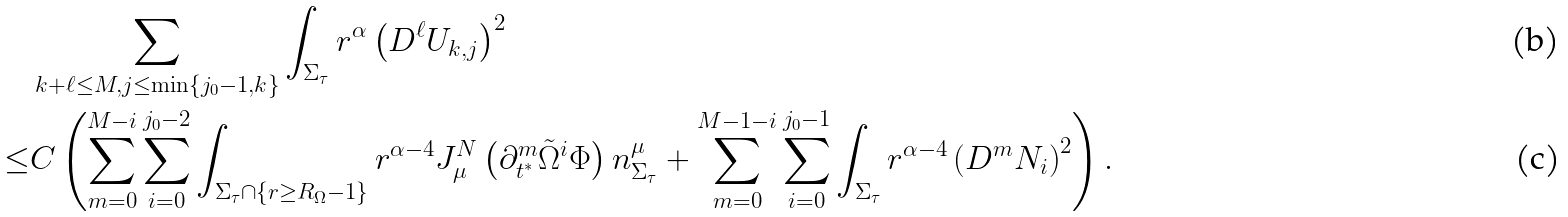<formula> <loc_0><loc_0><loc_500><loc_500>& \sum _ { k + \ell \leq M , j \leq \min \{ j _ { 0 } - 1 , k \} } \int _ { \Sigma _ { \tau } } r ^ { \alpha } \left ( D ^ { \ell } U _ { k , j } \right ) ^ { 2 } \\ \leq & C \left ( \sum _ { m = 0 } ^ { M - i } \sum _ { i = 0 } ^ { j _ { 0 } - 2 } \int _ { \Sigma _ { \tau } \cap \{ r \geq R _ { \Omega } - 1 \} } r ^ { \alpha - 4 } J ^ { N } _ { \mu } \left ( \partial _ { t ^ { * } } ^ { m } \tilde { \Omega } ^ { i } \Phi \right ) n ^ { \mu } _ { \Sigma _ { \tau } } + \sum _ { m = 0 } ^ { M - 1 - i } \sum _ { i = 0 } ^ { j _ { 0 } - 1 } \int _ { \Sigma _ { \tau } } r ^ { \alpha - 4 } \left ( D ^ { m } N _ { i } \right ) ^ { 2 } \right ) .</formula> 